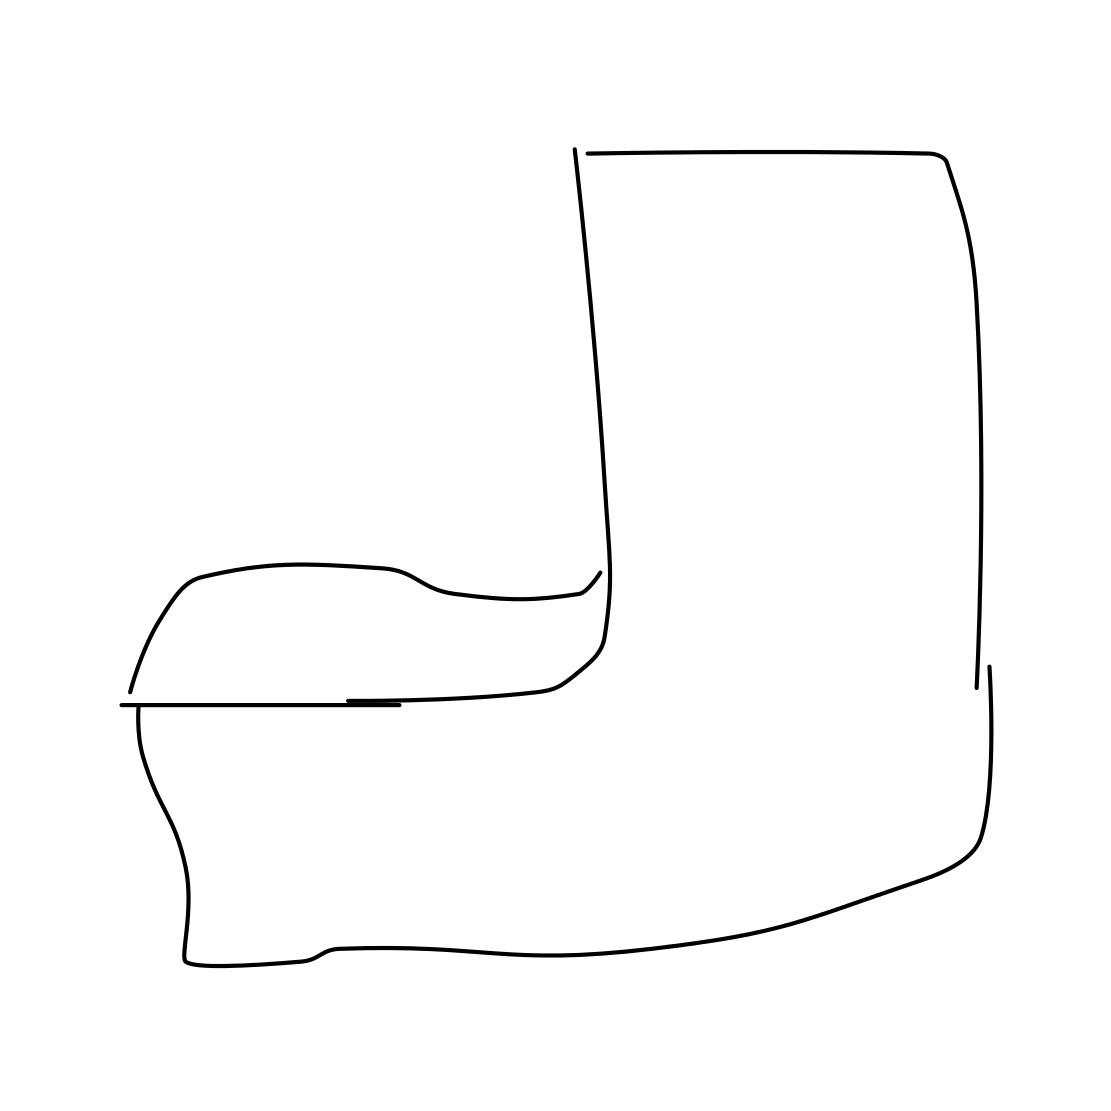What style of design does the armchair in the image represent? The armchair in the image exhibits a modern, minimalist design. It's characterized by its clean lines and absence of intricate details, reflecting a contemporary approach to furniture design that focuses on function and simplicity. Could you use this type of design in any decor? Absolutely, minimalist designs like this armchair are incredibly versatile. They can seamlessly blend into various interior decors, from ultra-modern to eclectic spaces that benefit from uncluttered and sleek furnishings. 